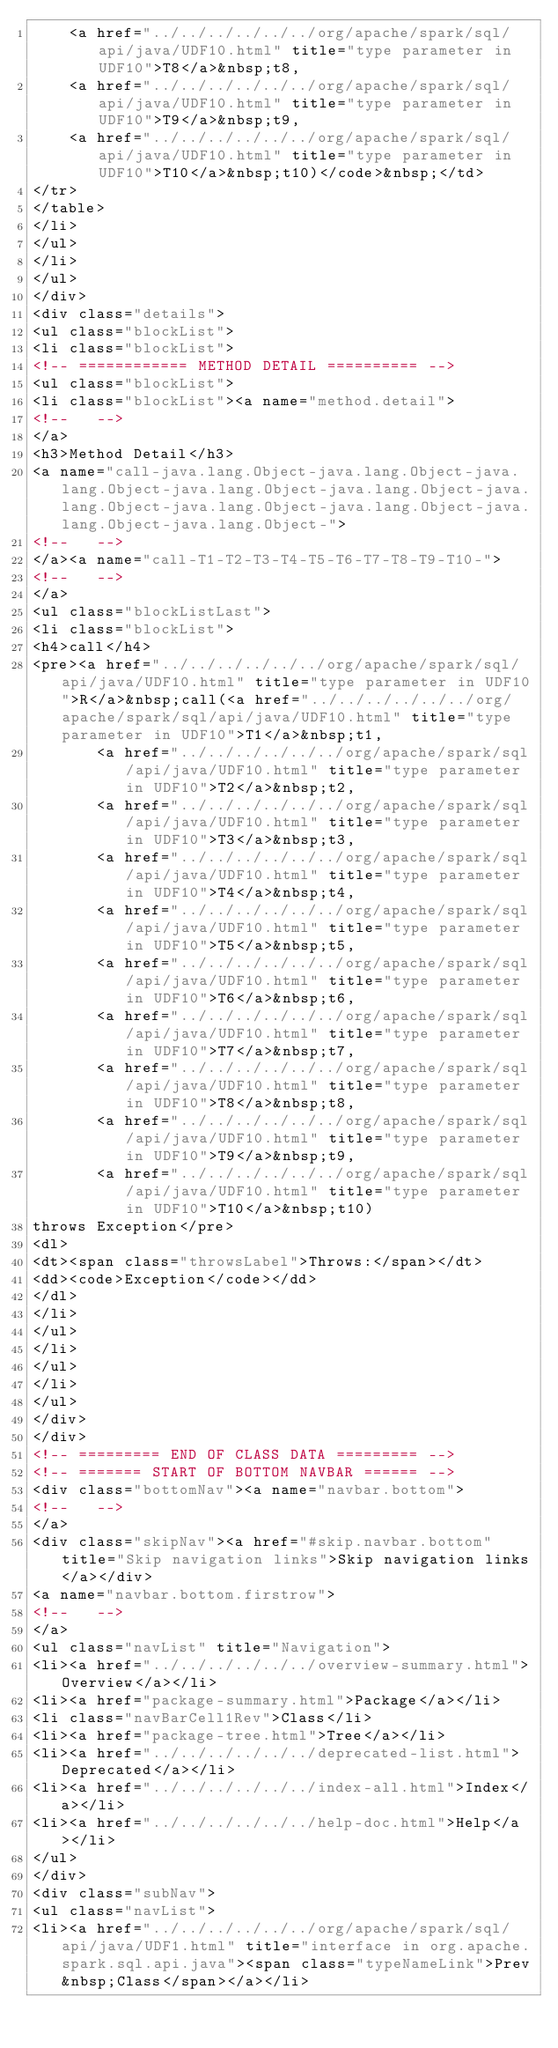<code> <loc_0><loc_0><loc_500><loc_500><_HTML_>    <a href="../../../../../../org/apache/spark/sql/api/java/UDF10.html" title="type parameter in UDF10">T8</a>&nbsp;t8,
    <a href="../../../../../../org/apache/spark/sql/api/java/UDF10.html" title="type parameter in UDF10">T9</a>&nbsp;t9,
    <a href="../../../../../../org/apache/spark/sql/api/java/UDF10.html" title="type parameter in UDF10">T10</a>&nbsp;t10)</code>&nbsp;</td>
</tr>
</table>
</li>
</ul>
</li>
</ul>
</div>
<div class="details">
<ul class="blockList">
<li class="blockList">
<!-- ============ METHOD DETAIL ========== -->
<ul class="blockList">
<li class="blockList"><a name="method.detail">
<!--   -->
</a>
<h3>Method Detail</h3>
<a name="call-java.lang.Object-java.lang.Object-java.lang.Object-java.lang.Object-java.lang.Object-java.lang.Object-java.lang.Object-java.lang.Object-java.lang.Object-java.lang.Object-">
<!--   -->
</a><a name="call-T1-T2-T3-T4-T5-T6-T7-T8-T9-T10-">
<!--   -->
</a>
<ul class="blockListLast">
<li class="blockList">
<h4>call</h4>
<pre><a href="../../../../../../org/apache/spark/sql/api/java/UDF10.html" title="type parameter in UDF10">R</a>&nbsp;call(<a href="../../../../../../org/apache/spark/sql/api/java/UDF10.html" title="type parameter in UDF10">T1</a>&nbsp;t1,
       <a href="../../../../../../org/apache/spark/sql/api/java/UDF10.html" title="type parameter in UDF10">T2</a>&nbsp;t2,
       <a href="../../../../../../org/apache/spark/sql/api/java/UDF10.html" title="type parameter in UDF10">T3</a>&nbsp;t3,
       <a href="../../../../../../org/apache/spark/sql/api/java/UDF10.html" title="type parameter in UDF10">T4</a>&nbsp;t4,
       <a href="../../../../../../org/apache/spark/sql/api/java/UDF10.html" title="type parameter in UDF10">T5</a>&nbsp;t5,
       <a href="../../../../../../org/apache/spark/sql/api/java/UDF10.html" title="type parameter in UDF10">T6</a>&nbsp;t6,
       <a href="../../../../../../org/apache/spark/sql/api/java/UDF10.html" title="type parameter in UDF10">T7</a>&nbsp;t7,
       <a href="../../../../../../org/apache/spark/sql/api/java/UDF10.html" title="type parameter in UDF10">T8</a>&nbsp;t8,
       <a href="../../../../../../org/apache/spark/sql/api/java/UDF10.html" title="type parameter in UDF10">T9</a>&nbsp;t9,
       <a href="../../../../../../org/apache/spark/sql/api/java/UDF10.html" title="type parameter in UDF10">T10</a>&nbsp;t10)
throws Exception</pre>
<dl>
<dt><span class="throwsLabel">Throws:</span></dt>
<dd><code>Exception</code></dd>
</dl>
</li>
</ul>
</li>
</ul>
</li>
</ul>
</div>
</div>
<!-- ========= END OF CLASS DATA ========= -->
<!-- ======= START OF BOTTOM NAVBAR ====== -->
<div class="bottomNav"><a name="navbar.bottom">
<!--   -->
</a>
<div class="skipNav"><a href="#skip.navbar.bottom" title="Skip navigation links">Skip navigation links</a></div>
<a name="navbar.bottom.firstrow">
<!--   -->
</a>
<ul class="navList" title="Navigation">
<li><a href="../../../../../../overview-summary.html">Overview</a></li>
<li><a href="package-summary.html">Package</a></li>
<li class="navBarCell1Rev">Class</li>
<li><a href="package-tree.html">Tree</a></li>
<li><a href="../../../../../../deprecated-list.html">Deprecated</a></li>
<li><a href="../../../../../../index-all.html">Index</a></li>
<li><a href="../../../../../../help-doc.html">Help</a></li>
</ul>
</div>
<div class="subNav">
<ul class="navList">
<li><a href="../../../../../../org/apache/spark/sql/api/java/UDF1.html" title="interface in org.apache.spark.sql.api.java"><span class="typeNameLink">Prev&nbsp;Class</span></a></li></code> 